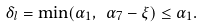<formula> <loc_0><loc_0><loc_500><loc_500>\delta _ { l } = \min ( \alpha _ { 1 } , \ \alpha _ { 7 } - \xi ) \leq \alpha _ { 1 } .</formula> 